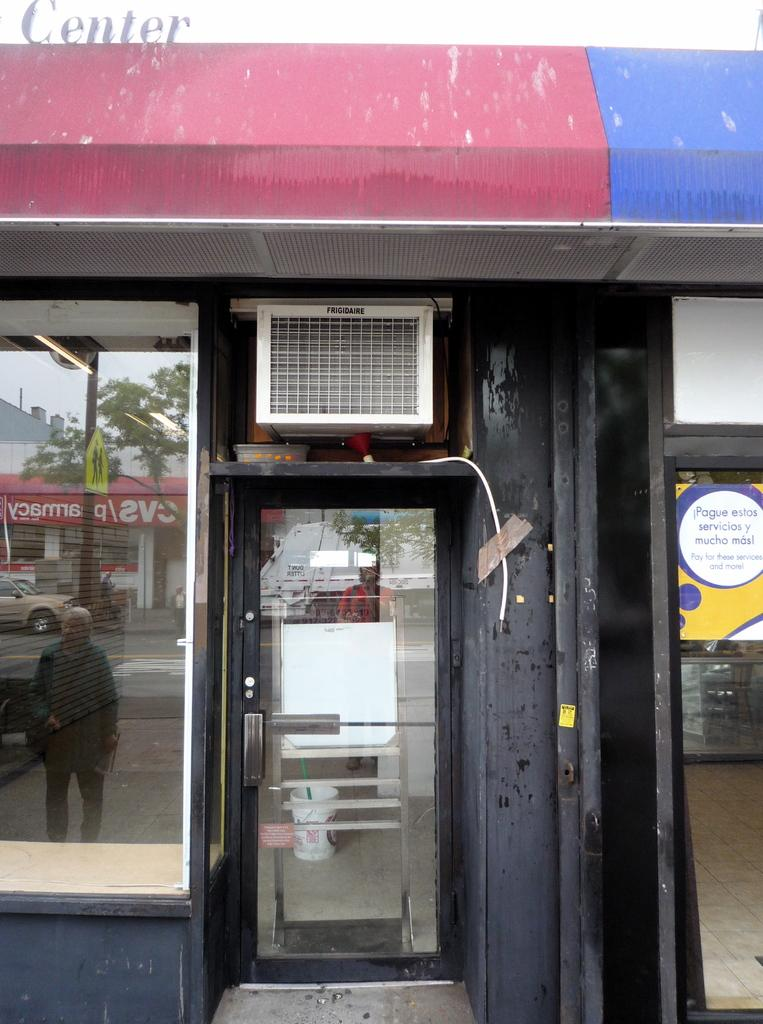What is one of the objects visible in the image? There is a door in the image. What else can be seen in the image besides the door? There is a bucket, a poster, a signboard, a pole, a car, a person walking on the road, buildings, and trees visible in the image. Can you describe the type of vehicle in the image? There is a car in the image. What is the person in the image doing? There is a person walking on the road in the image. What type of structures are visible in the image? There are buildings in the image. What type of vegetation is visible in the image? There are trees in the image. What type of love can be seen growing on the pole in the image? There is no love growing on the pole in the image; it is a pole with no such growth. What type of spade is being used to dig a hole in the image? There is no spade present in the image, and therefore no digging activity can be observed. 